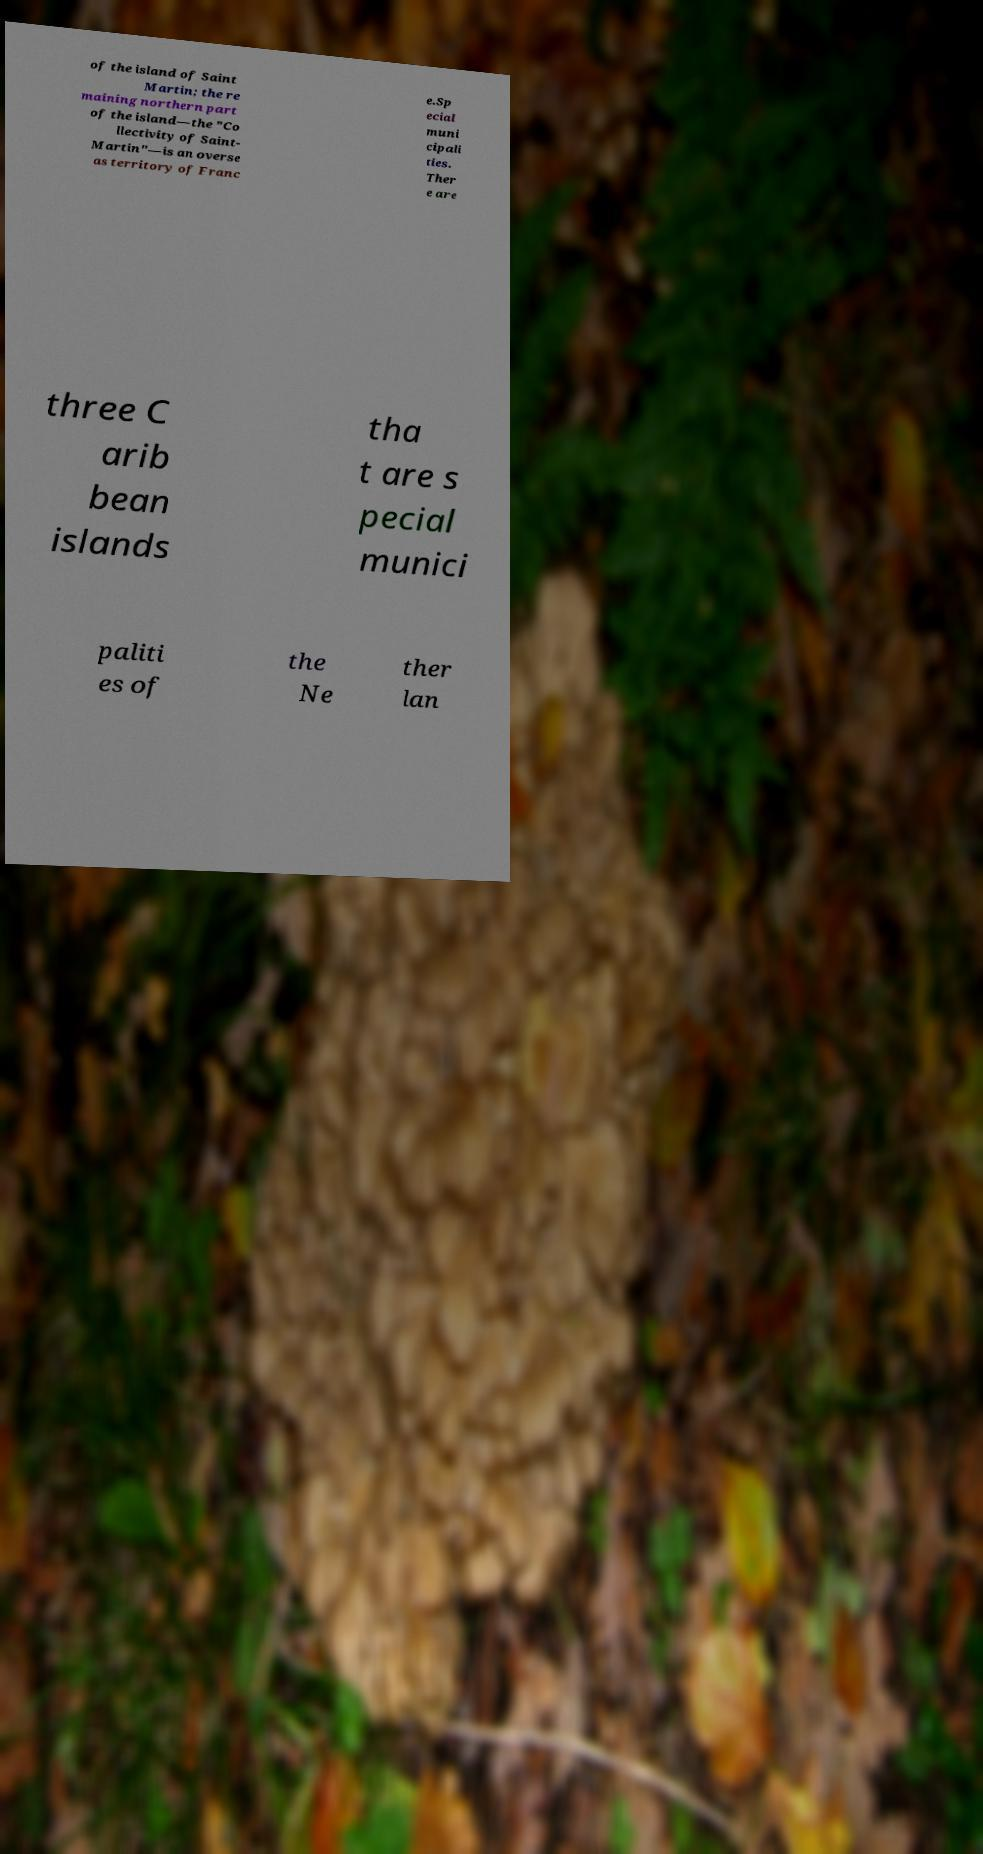Please identify and transcribe the text found in this image. of the island of Saint Martin; the re maining northern part of the island—the "Co llectivity of Saint- Martin"—is an overse as territory of Franc e.Sp ecial muni cipali ties. Ther e are three C arib bean islands tha t are s pecial munici paliti es of the Ne ther lan 